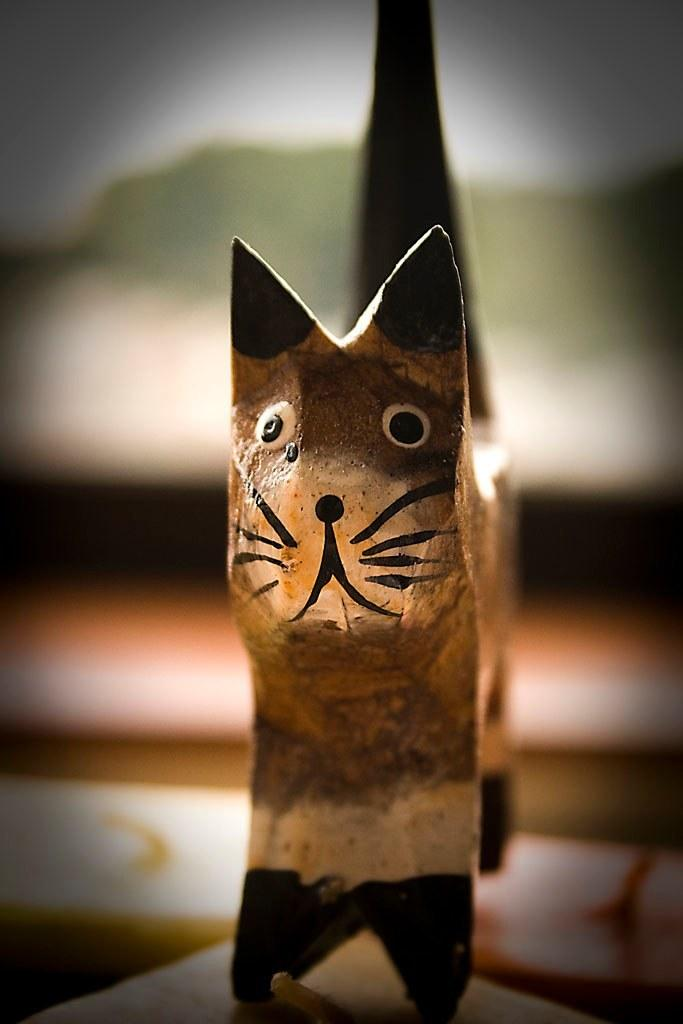What is the main subject of the image? The main subject of the image is an object on the table. Can you describe the object on the table? Unfortunately, the provided facts do not give any details about the object on the table. However, we can still discuss the presence of the object and its location. Where is the object located in the image? The object is located on the table in the image. How many planes can be seen flying over the girl in the image? There is no girl or planes present in the image; it only features an object on the table. 